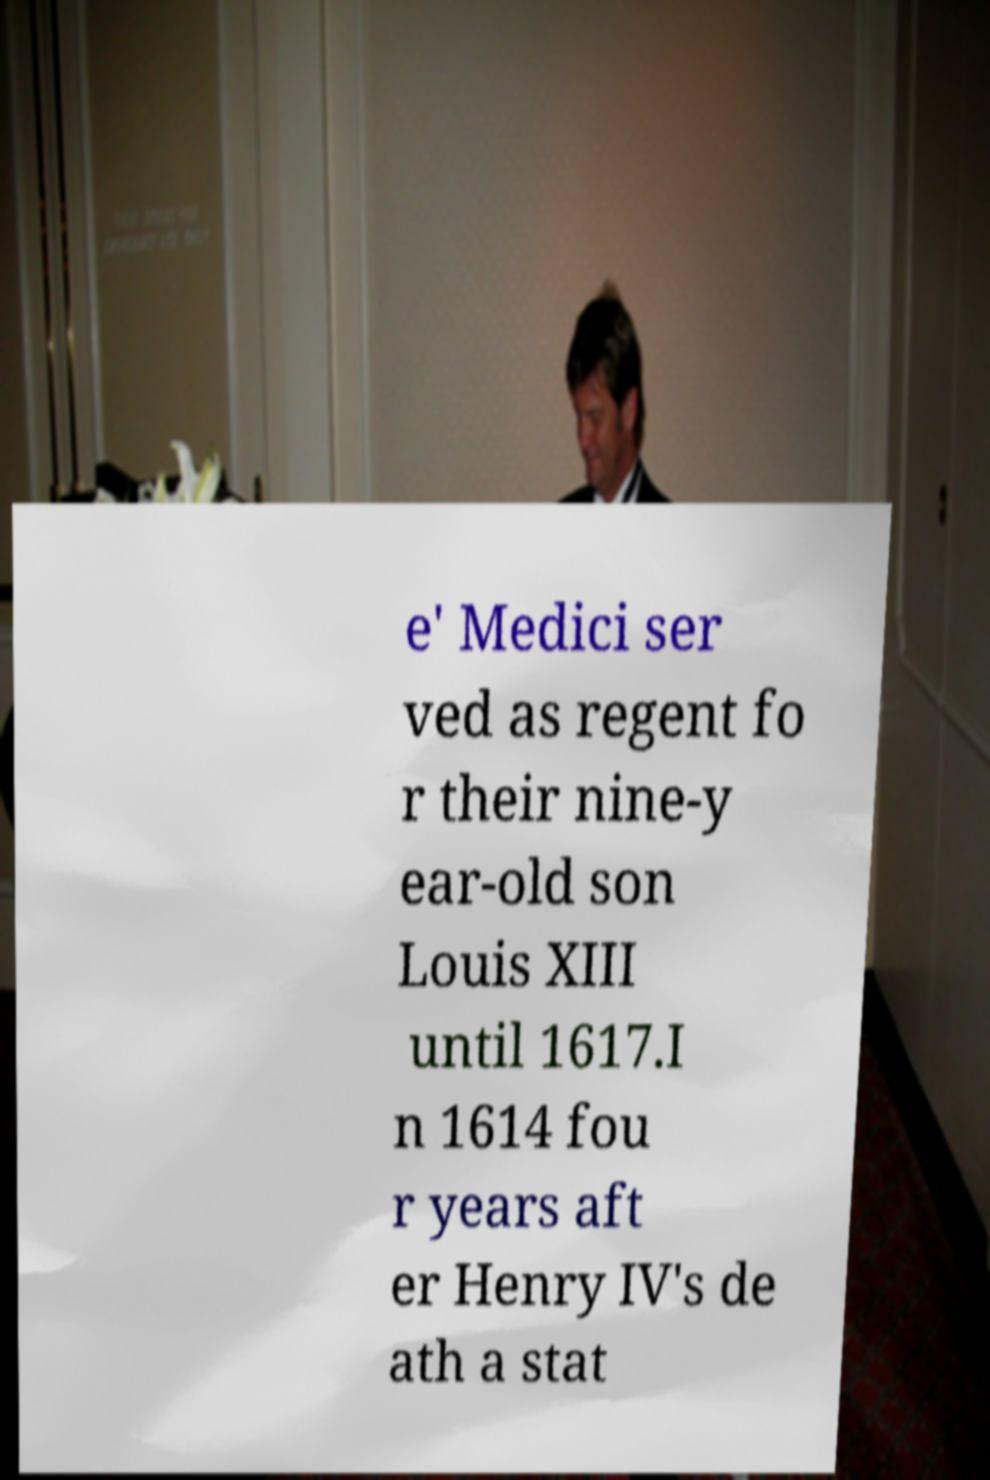Could you assist in decoding the text presented in this image and type it out clearly? e' Medici ser ved as regent fo r their nine-y ear-old son Louis XIII until 1617.I n 1614 fou r years aft er Henry IV's de ath a stat 